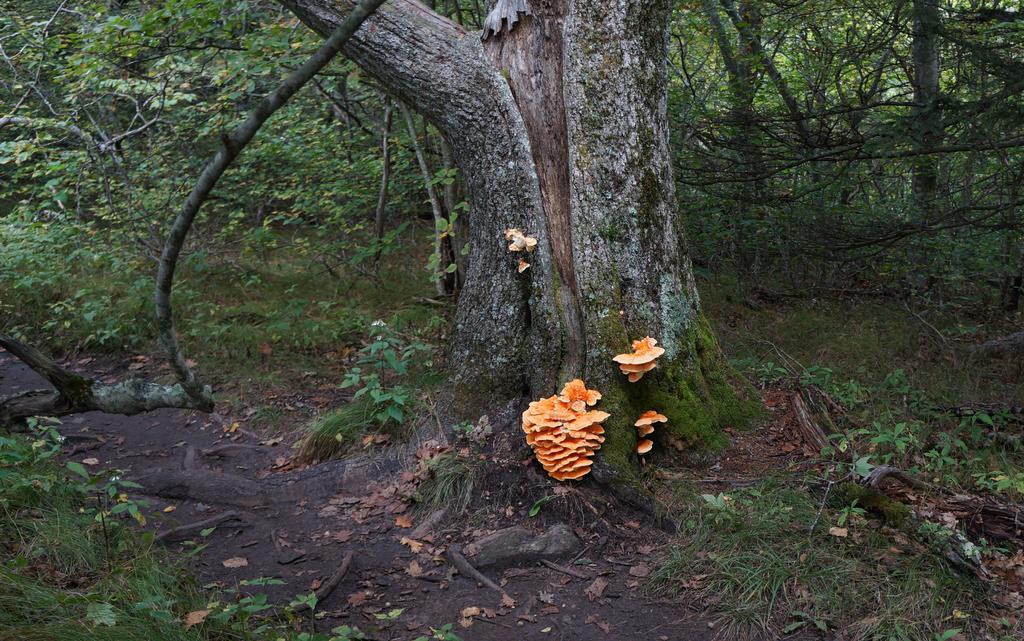Describe this image in one or two sentences. In the image there is fungus mould to tree along with algae to its stem on the land, there are many plants and trees all over the place. 